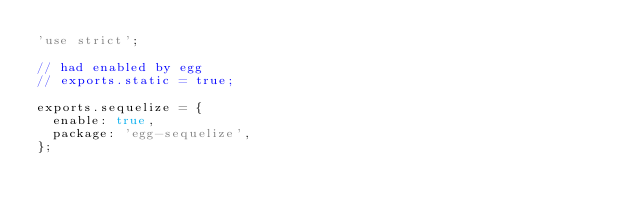<code> <loc_0><loc_0><loc_500><loc_500><_JavaScript_>'use strict';

// had enabled by egg
// exports.static = true;

exports.sequelize = {
  enable: true,
  package: 'egg-sequelize',
};
</code> 